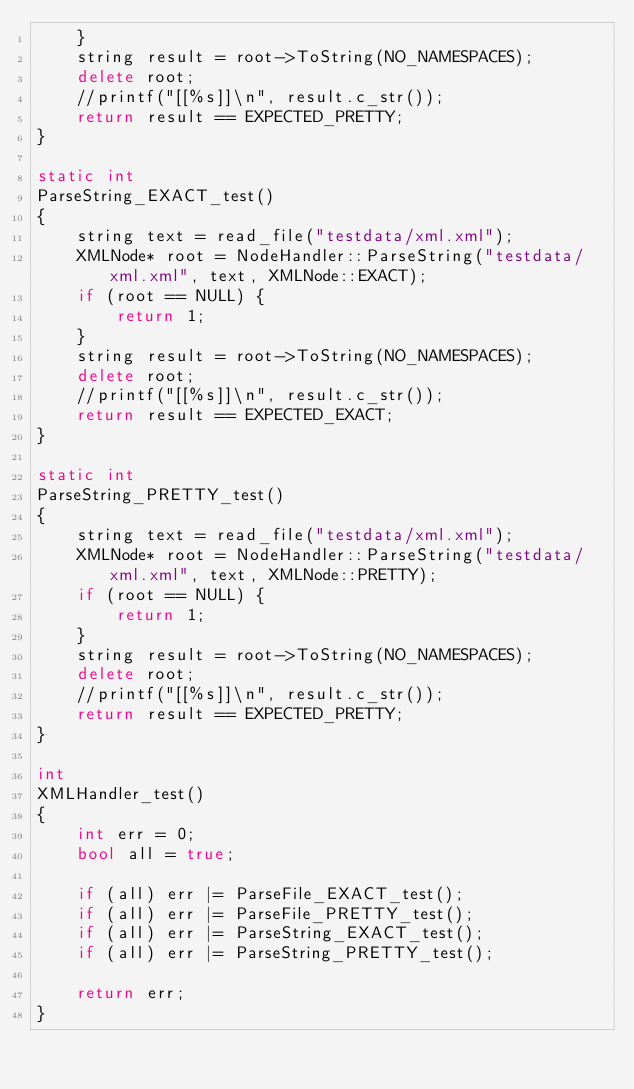<code> <loc_0><loc_0><loc_500><loc_500><_C++_>    }
    string result = root->ToString(NO_NAMESPACES);
    delete root;
    //printf("[[%s]]\n", result.c_str());
    return result == EXPECTED_PRETTY;
}

static int
ParseString_EXACT_test()
{
    string text = read_file("testdata/xml.xml");
    XMLNode* root = NodeHandler::ParseString("testdata/xml.xml", text, XMLNode::EXACT);
    if (root == NULL) {
        return 1;
    }
    string result = root->ToString(NO_NAMESPACES);
    delete root;
    //printf("[[%s]]\n", result.c_str());
    return result == EXPECTED_EXACT;
}

static int
ParseString_PRETTY_test()
{
    string text = read_file("testdata/xml.xml");
    XMLNode* root = NodeHandler::ParseString("testdata/xml.xml", text, XMLNode::PRETTY);
    if (root == NULL) {
        return 1;
    }
    string result = root->ToString(NO_NAMESPACES);
    delete root;
    //printf("[[%s]]\n", result.c_str());
    return result == EXPECTED_PRETTY;
}

int
XMLHandler_test()
{
    int err = 0;
    bool all = true;

    if (all) err |= ParseFile_EXACT_test();
    if (all) err |= ParseFile_PRETTY_test();
    if (all) err |= ParseString_EXACT_test();
    if (all) err |= ParseString_PRETTY_test();

    return err;
}
</code> 